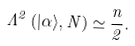<formula> <loc_0><loc_0><loc_500><loc_500>\Lambda ^ { 2 } \left ( | \alpha \rangle , N \right ) \simeq \frac { n } { 2 } .</formula> 